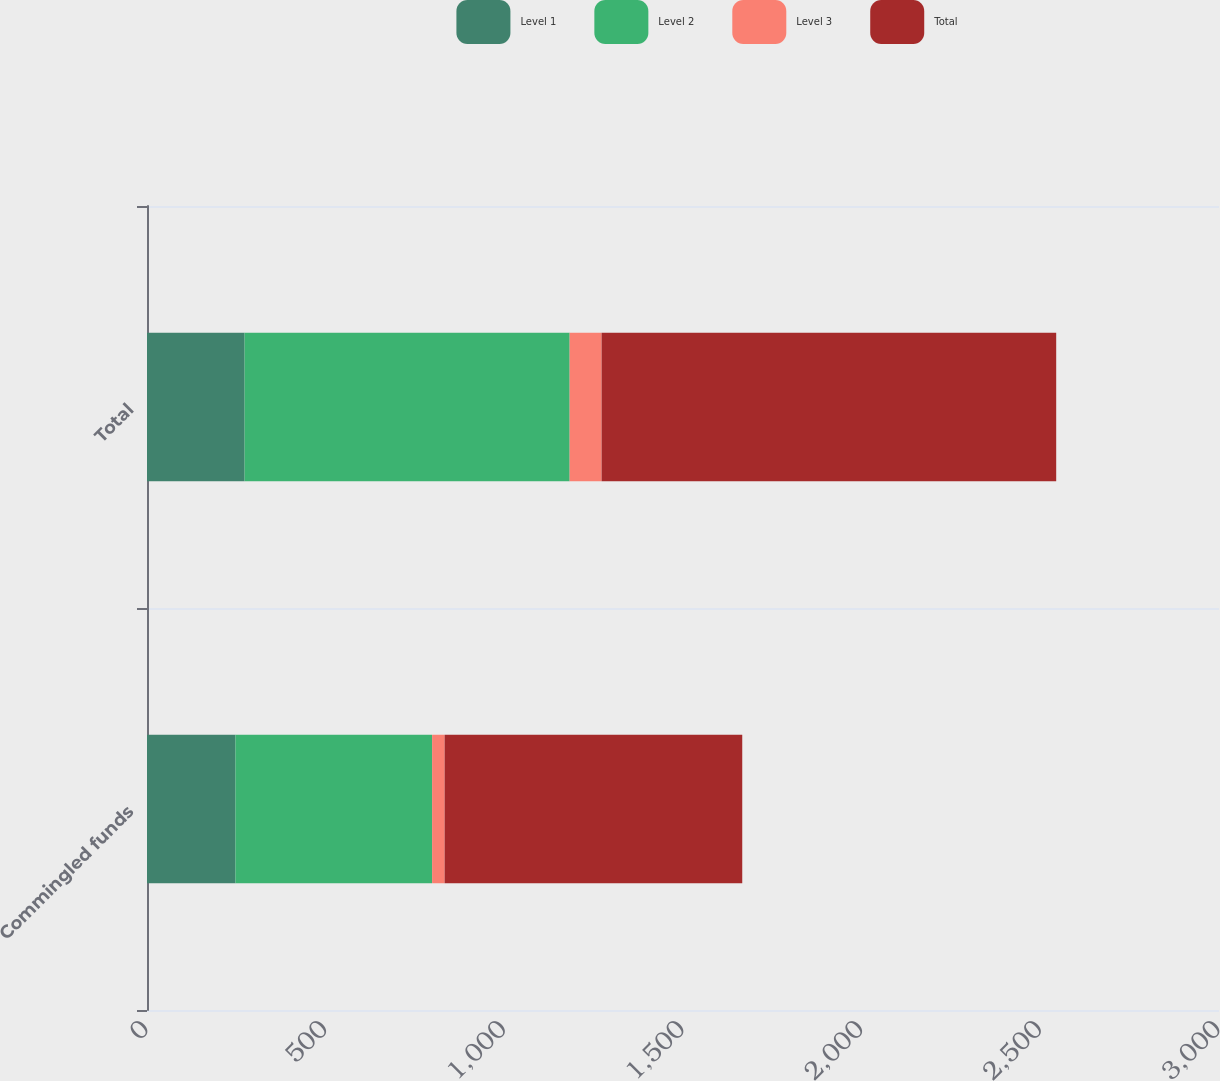Convert chart to OTSL. <chart><loc_0><loc_0><loc_500><loc_500><stacked_bar_chart><ecel><fcel>Commingled funds<fcel>Total<nl><fcel>Level 1<fcel>247.5<fcel>273.1<nl><fcel>Level 2<fcel>550.4<fcel>909.7<nl><fcel>Level 3<fcel>35<fcel>89.4<nl><fcel>Total<fcel>832.9<fcel>1272.2<nl></chart> 